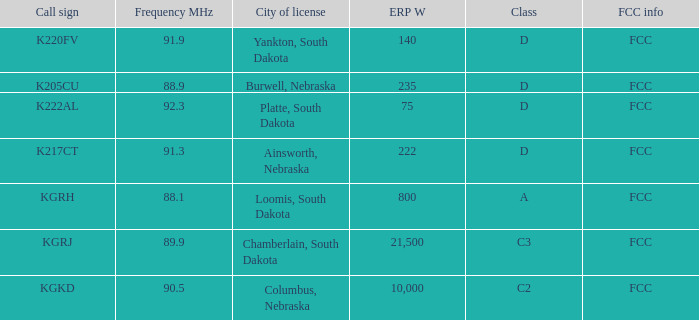What is the total erp w of class c3, which has a frequency mhz less than 89.9? 0.0. 